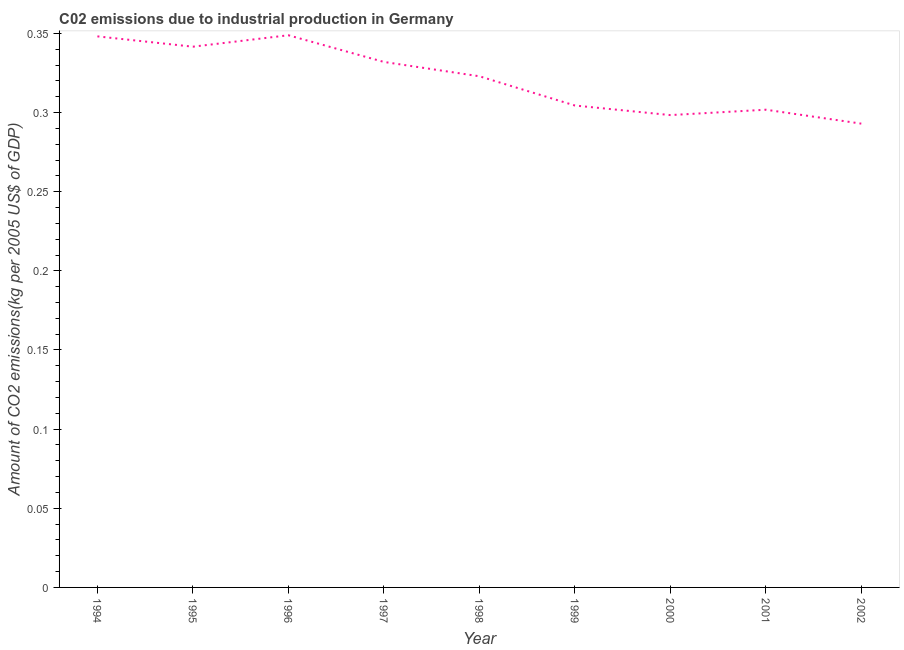What is the amount of co2 emissions in 1995?
Keep it short and to the point. 0.34. Across all years, what is the maximum amount of co2 emissions?
Your response must be concise. 0.35. Across all years, what is the minimum amount of co2 emissions?
Give a very brief answer. 0.29. What is the sum of the amount of co2 emissions?
Ensure brevity in your answer.  2.89. What is the difference between the amount of co2 emissions in 1997 and 1999?
Offer a very short reply. 0.03. What is the average amount of co2 emissions per year?
Your answer should be compact. 0.32. What is the median amount of co2 emissions?
Keep it short and to the point. 0.32. In how many years, is the amount of co2 emissions greater than 0.07 kg per 2005 US$ of GDP?
Provide a succinct answer. 9. Do a majority of the years between 1998 and 2001 (inclusive) have amount of co2 emissions greater than 0.31000000000000005 kg per 2005 US$ of GDP?
Your answer should be very brief. No. What is the ratio of the amount of co2 emissions in 1995 to that in 2001?
Make the answer very short. 1.13. Is the amount of co2 emissions in 1995 less than that in 2000?
Keep it short and to the point. No. Is the difference between the amount of co2 emissions in 1998 and 1999 greater than the difference between any two years?
Provide a succinct answer. No. What is the difference between the highest and the second highest amount of co2 emissions?
Offer a terse response. 0. What is the difference between the highest and the lowest amount of co2 emissions?
Keep it short and to the point. 0.06. In how many years, is the amount of co2 emissions greater than the average amount of co2 emissions taken over all years?
Keep it short and to the point. 5. How many lines are there?
Your answer should be compact. 1. How many years are there in the graph?
Offer a very short reply. 9. Are the values on the major ticks of Y-axis written in scientific E-notation?
Give a very brief answer. No. What is the title of the graph?
Offer a very short reply. C02 emissions due to industrial production in Germany. What is the label or title of the X-axis?
Offer a very short reply. Year. What is the label or title of the Y-axis?
Provide a short and direct response. Amount of CO2 emissions(kg per 2005 US$ of GDP). What is the Amount of CO2 emissions(kg per 2005 US$ of GDP) of 1994?
Your answer should be very brief. 0.35. What is the Amount of CO2 emissions(kg per 2005 US$ of GDP) of 1995?
Your answer should be compact. 0.34. What is the Amount of CO2 emissions(kg per 2005 US$ of GDP) in 1996?
Your response must be concise. 0.35. What is the Amount of CO2 emissions(kg per 2005 US$ of GDP) of 1997?
Ensure brevity in your answer.  0.33. What is the Amount of CO2 emissions(kg per 2005 US$ of GDP) of 1998?
Your answer should be very brief. 0.32. What is the Amount of CO2 emissions(kg per 2005 US$ of GDP) of 1999?
Your response must be concise. 0.3. What is the Amount of CO2 emissions(kg per 2005 US$ of GDP) of 2000?
Offer a very short reply. 0.3. What is the Amount of CO2 emissions(kg per 2005 US$ of GDP) of 2001?
Give a very brief answer. 0.3. What is the Amount of CO2 emissions(kg per 2005 US$ of GDP) in 2002?
Offer a terse response. 0.29. What is the difference between the Amount of CO2 emissions(kg per 2005 US$ of GDP) in 1994 and 1995?
Provide a short and direct response. 0.01. What is the difference between the Amount of CO2 emissions(kg per 2005 US$ of GDP) in 1994 and 1996?
Make the answer very short. -0. What is the difference between the Amount of CO2 emissions(kg per 2005 US$ of GDP) in 1994 and 1997?
Offer a terse response. 0.02. What is the difference between the Amount of CO2 emissions(kg per 2005 US$ of GDP) in 1994 and 1998?
Give a very brief answer. 0.03. What is the difference between the Amount of CO2 emissions(kg per 2005 US$ of GDP) in 1994 and 1999?
Give a very brief answer. 0.04. What is the difference between the Amount of CO2 emissions(kg per 2005 US$ of GDP) in 1994 and 2000?
Make the answer very short. 0.05. What is the difference between the Amount of CO2 emissions(kg per 2005 US$ of GDP) in 1994 and 2001?
Offer a very short reply. 0.05. What is the difference between the Amount of CO2 emissions(kg per 2005 US$ of GDP) in 1994 and 2002?
Provide a short and direct response. 0.06. What is the difference between the Amount of CO2 emissions(kg per 2005 US$ of GDP) in 1995 and 1996?
Provide a succinct answer. -0.01. What is the difference between the Amount of CO2 emissions(kg per 2005 US$ of GDP) in 1995 and 1997?
Ensure brevity in your answer.  0.01. What is the difference between the Amount of CO2 emissions(kg per 2005 US$ of GDP) in 1995 and 1998?
Offer a terse response. 0.02. What is the difference between the Amount of CO2 emissions(kg per 2005 US$ of GDP) in 1995 and 1999?
Your response must be concise. 0.04. What is the difference between the Amount of CO2 emissions(kg per 2005 US$ of GDP) in 1995 and 2000?
Give a very brief answer. 0.04. What is the difference between the Amount of CO2 emissions(kg per 2005 US$ of GDP) in 1995 and 2001?
Provide a succinct answer. 0.04. What is the difference between the Amount of CO2 emissions(kg per 2005 US$ of GDP) in 1995 and 2002?
Ensure brevity in your answer.  0.05. What is the difference between the Amount of CO2 emissions(kg per 2005 US$ of GDP) in 1996 and 1997?
Offer a very short reply. 0.02. What is the difference between the Amount of CO2 emissions(kg per 2005 US$ of GDP) in 1996 and 1998?
Your response must be concise. 0.03. What is the difference between the Amount of CO2 emissions(kg per 2005 US$ of GDP) in 1996 and 1999?
Provide a succinct answer. 0.04. What is the difference between the Amount of CO2 emissions(kg per 2005 US$ of GDP) in 1996 and 2000?
Your response must be concise. 0.05. What is the difference between the Amount of CO2 emissions(kg per 2005 US$ of GDP) in 1996 and 2001?
Offer a very short reply. 0.05. What is the difference between the Amount of CO2 emissions(kg per 2005 US$ of GDP) in 1996 and 2002?
Ensure brevity in your answer.  0.06. What is the difference between the Amount of CO2 emissions(kg per 2005 US$ of GDP) in 1997 and 1998?
Make the answer very short. 0.01. What is the difference between the Amount of CO2 emissions(kg per 2005 US$ of GDP) in 1997 and 1999?
Provide a succinct answer. 0.03. What is the difference between the Amount of CO2 emissions(kg per 2005 US$ of GDP) in 1997 and 2000?
Your answer should be compact. 0.03. What is the difference between the Amount of CO2 emissions(kg per 2005 US$ of GDP) in 1997 and 2001?
Your answer should be compact. 0.03. What is the difference between the Amount of CO2 emissions(kg per 2005 US$ of GDP) in 1997 and 2002?
Offer a very short reply. 0.04. What is the difference between the Amount of CO2 emissions(kg per 2005 US$ of GDP) in 1998 and 1999?
Give a very brief answer. 0.02. What is the difference between the Amount of CO2 emissions(kg per 2005 US$ of GDP) in 1998 and 2000?
Provide a short and direct response. 0.02. What is the difference between the Amount of CO2 emissions(kg per 2005 US$ of GDP) in 1998 and 2001?
Offer a terse response. 0.02. What is the difference between the Amount of CO2 emissions(kg per 2005 US$ of GDP) in 1998 and 2002?
Your response must be concise. 0.03. What is the difference between the Amount of CO2 emissions(kg per 2005 US$ of GDP) in 1999 and 2000?
Make the answer very short. 0.01. What is the difference between the Amount of CO2 emissions(kg per 2005 US$ of GDP) in 1999 and 2001?
Offer a very short reply. 0. What is the difference between the Amount of CO2 emissions(kg per 2005 US$ of GDP) in 1999 and 2002?
Ensure brevity in your answer.  0.01. What is the difference between the Amount of CO2 emissions(kg per 2005 US$ of GDP) in 2000 and 2001?
Offer a terse response. -0. What is the difference between the Amount of CO2 emissions(kg per 2005 US$ of GDP) in 2000 and 2002?
Your response must be concise. 0.01. What is the difference between the Amount of CO2 emissions(kg per 2005 US$ of GDP) in 2001 and 2002?
Your answer should be very brief. 0.01. What is the ratio of the Amount of CO2 emissions(kg per 2005 US$ of GDP) in 1994 to that in 1995?
Provide a succinct answer. 1.02. What is the ratio of the Amount of CO2 emissions(kg per 2005 US$ of GDP) in 1994 to that in 1996?
Your answer should be very brief. 1. What is the ratio of the Amount of CO2 emissions(kg per 2005 US$ of GDP) in 1994 to that in 1997?
Keep it short and to the point. 1.05. What is the ratio of the Amount of CO2 emissions(kg per 2005 US$ of GDP) in 1994 to that in 1998?
Provide a succinct answer. 1.08. What is the ratio of the Amount of CO2 emissions(kg per 2005 US$ of GDP) in 1994 to that in 1999?
Your answer should be very brief. 1.14. What is the ratio of the Amount of CO2 emissions(kg per 2005 US$ of GDP) in 1994 to that in 2000?
Keep it short and to the point. 1.17. What is the ratio of the Amount of CO2 emissions(kg per 2005 US$ of GDP) in 1994 to that in 2001?
Your answer should be very brief. 1.15. What is the ratio of the Amount of CO2 emissions(kg per 2005 US$ of GDP) in 1994 to that in 2002?
Your answer should be very brief. 1.19. What is the ratio of the Amount of CO2 emissions(kg per 2005 US$ of GDP) in 1995 to that in 1998?
Ensure brevity in your answer.  1.06. What is the ratio of the Amount of CO2 emissions(kg per 2005 US$ of GDP) in 1995 to that in 1999?
Give a very brief answer. 1.12. What is the ratio of the Amount of CO2 emissions(kg per 2005 US$ of GDP) in 1995 to that in 2000?
Your answer should be compact. 1.15. What is the ratio of the Amount of CO2 emissions(kg per 2005 US$ of GDP) in 1995 to that in 2001?
Make the answer very short. 1.13. What is the ratio of the Amount of CO2 emissions(kg per 2005 US$ of GDP) in 1995 to that in 2002?
Give a very brief answer. 1.17. What is the ratio of the Amount of CO2 emissions(kg per 2005 US$ of GDP) in 1996 to that in 1997?
Your response must be concise. 1.05. What is the ratio of the Amount of CO2 emissions(kg per 2005 US$ of GDP) in 1996 to that in 1999?
Your answer should be very brief. 1.15. What is the ratio of the Amount of CO2 emissions(kg per 2005 US$ of GDP) in 1996 to that in 2000?
Provide a succinct answer. 1.17. What is the ratio of the Amount of CO2 emissions(kg per 2005 US$ of GDP) in 1996 to that in 2001?
Your answer should be very brief. 1.16. What is the ratio of the Amount of CO2 emissions(kg per 2005 US$ of GDP) in 1996 to that in 2002?
Your answer should be very brief. 1.19. What is the ratio of the Amount of CO2 emissions(kg per 2005 US$ of GDP) in 1997 to that in 1998?
Offer a very short reply. 1.03. What is the ratio of the Amount of CO2 emissions(kg per 2005 US$ of GDP) in 1997 to that in 1999?
Give a very brief answer. 1.09. What is the ratio of the Amount of CO2 emissions(kg per 2005 US$ of GDP) in 1997 to that in 2000?
Your answer should be compact. 1.11. What is the ratio of the Amount of CO2 emissions(kg per 2005 US$ of GDP) in 1997 to that in 2001?
Offer a very short reply. 1.1. What is the ratio of the Amount of CO2 emissions(kg per 2005 US$ of GDP) in 1997 to that in 2002?
Provide a succinct answer. 1.13. What is the ratio of the Amount of CO2 emissions(kg per 2005 US$ of GDP) in 1998 to that in 1999?
Give a very brief answer. 1.06. What is the ratio of the Amount of CO2 emissions(kg per 2005 US$ of GDP) in 1998 to that in 2000?
Provide a succinct answer. 1.08. What is the ratio of the Amount of CO2 emissions(kg per 2005 US$ of GDP) in 1998 to that in 2001?
Offer a terse response. 1.07. What is the ratio of the Amount of CO2 emissions(kg per 2005 US$ of GDP) in 1998 to that in 2002?
Give a very brief answer. 1.1. What is the ratio of the Amount of CO2 emissions(kg per 2005 US$ of GDP) in 1999 to that in 2001?
Your answer should be compact. 1.01. What is the ratio of the Amount of CO2 emissions(kg per 2005 US$ of GDP) in 1999 to that in 2002?
Ensure brevity in your answer.  1.04. What is the ratio of the Amount of CO2 emissions(kg per 2005 US$ of GDP) in 2000 to that in 2001?
Make the answer very short. 0.99. What is the ratio of the Amount of CO2 emissions(kg per 2005 US$ of GDP) in 2000 to that in 2002?
Give a very brief answer. 1.02. 